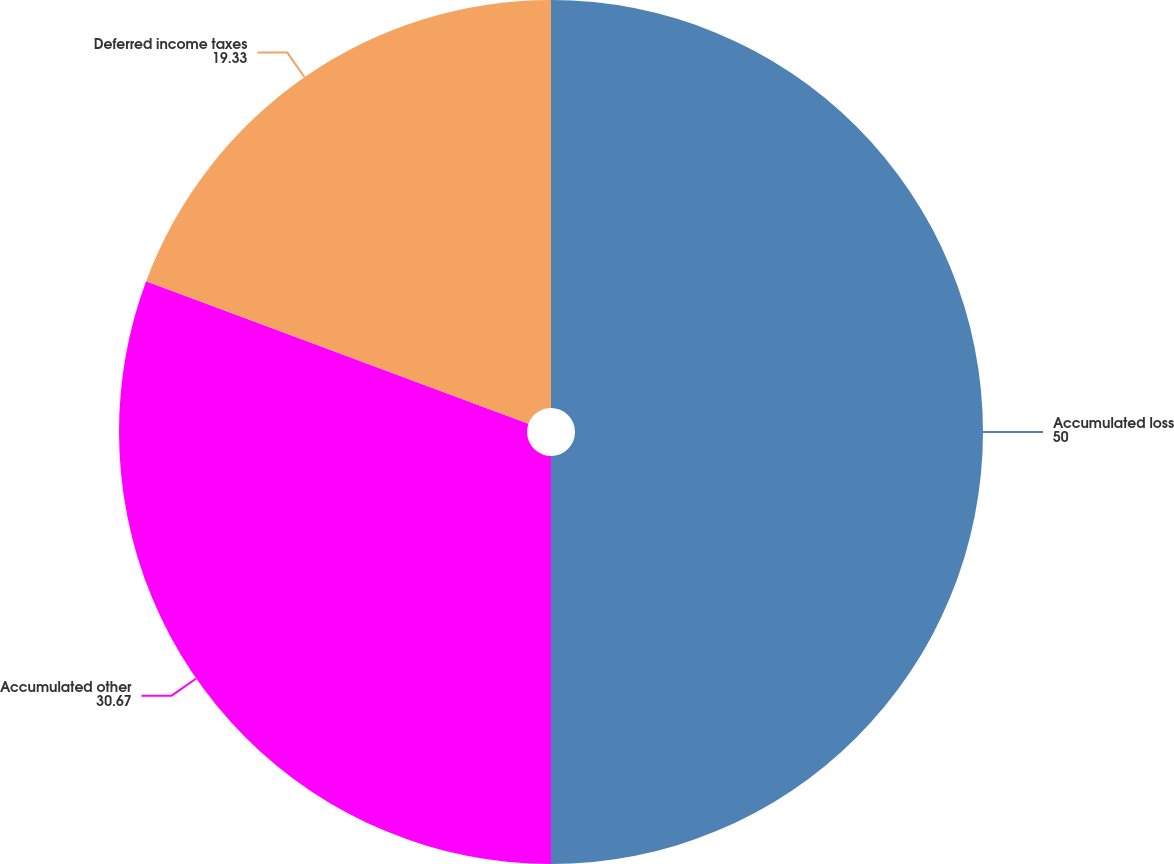Convert chart. <chart><loc_0><loc_0><loc_500><loc_500><pie_chart><fcel>Accumulated loss<fcel>Accumulated other<fcel>Deferred income taxes<nl><fcel>50.0%<fcel>30.67%<fcel>19.33%<nl></chart> 